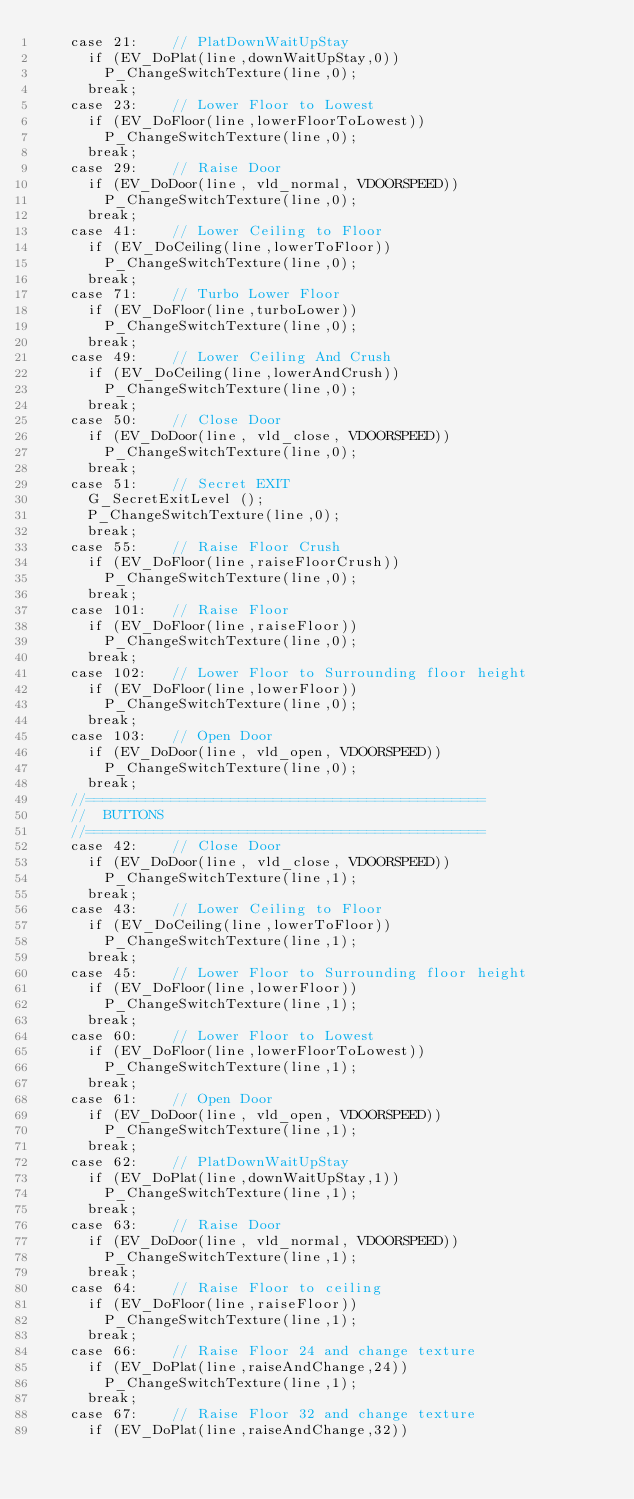Convert code to text. <code><loc_0><loc_0><loc_500><loc_500><_C_>		case 21:		// PlatDownWaitUpStay
			if (EV_DoPlat(line,downWaitUpStay,0))
				P_ChangeSwitchTexture(line,0);
			break;
		case 23:		// Lower Floor to Lowest
			if (EV_DoFloor(line,lowerFloorToLowest))
				P_ChangeSwitchTexture(line,0);
			break;
		case 29:		// Raise Door
			if (EV_DoDoor(line, vld_normal, VDOORSPEED))
				P_ChangeSwitchTexture(line,0);
			break;
		case 41:		// Lower Ceiling to Floor
			if (EV_DoCeiling(line,lowerToFloor))
				P_ChangeSwitchTexture(line,0);
			break;
		case 71:		// Turbo Lower Floor
			if (EV_DoFloor(line,turboLower))
				P_ChangeSwitchTexture(line,0);
			break;
		case 49:		// Lower Ceiling And Crush
			if (EV_DoCeiling(line,lowerAndCrush))
				P_ChangeSwitchTexture(line,0);
			break;
		case 50:		// Close Door
			if (EV_DoDoor(line, vld_close, VDOORSPEED))
				P_ChangeSwitchTexture(line,0);
			break;
		case 51:		// Secret EXIT
			G_SecretExitLevel ();
			P_ChangeSwitchTexture(line,0);
			break;
		case 55:		// Raise Floor Crush
			if (EV_DoFloor(line,raiseFloorCrush))
				P_ChangeSwitchTexture(line,0);
			break;
		case 101:		// Raise Floor
			if (EV_DoFloor(line,raiseFloor))
				P_ChangeSwitchTexture(line,0);
			break;
		case 102:		// Lower Floor to Surrounding floor height
			if (EV_DoFloor(line,lowerFloor))
				P_ChangeSwitchTexture(line,0);
			break;
		case 103:		// Open Door
			if (EV_DoDoor(line, vld_open, VDOORSPEED))
				P_ChangeSwitchTexture(line,0);
			break;
		//===============================================
		//	BUTTONS
		//===============================================
		case 42:		// Close Door
			if (EV_DoDoor(line, vld_close, VDOORSPEED))
				P_ChangeSwitchTexture(line,1);
			break;
		case 43:		// Lower Ceiling to Floor
			if (EV_DoCeiling(line,lowerToFloor))
				P_ChangeSwitchTexture(line,1);
			break;
		case 45:		// Lower Floor to Surrounding floor height
			if (EV_DoFloor(line,lowerFloor))
				P_ChangeSwitchTexture(line,1);
			break;
		case 60:		// Lower Floor to Lowest
			if (EV_DoFloor(line,lowerFloorToLowest))
				P_ChangeSwitchTexture(line,1);
			break;
		case 61:		// Open Door
			if (EV_DoDoor(line, vld_open, VDOORSPEED))
				P_ChangeSwitchTexture(line,1);
			break;
		case 62:		// PlatDownWaitUpStay
			if (EV_DoPlat(line,downWaitUpStay,1))
				P_ChangeSwitchTexture(line,1);
			break;
		case 63:		// Raise Door
			if (EV_DoDoor(line, vld_normal, VDOORSPEED))
				P_ChangeSwitchTexture(line,1);
			break;
		case 64:		// Raise Floor to ceiling
			if (EV_DoFloor(line,raiseFloor))
				P_ChangeSwitchTexture(line,1);
			break;
		case 66:		// Raise Floor 24 and change texture
			if (EV_DoPlat(line,raiseAndChange,24))
				P_ChangeSwitchTexture(line,1);
			break;
		case 67:		// Raise Floor 32 and change texture
			if (EV_DoPlat(line,raiseAndChange,32))</code> 